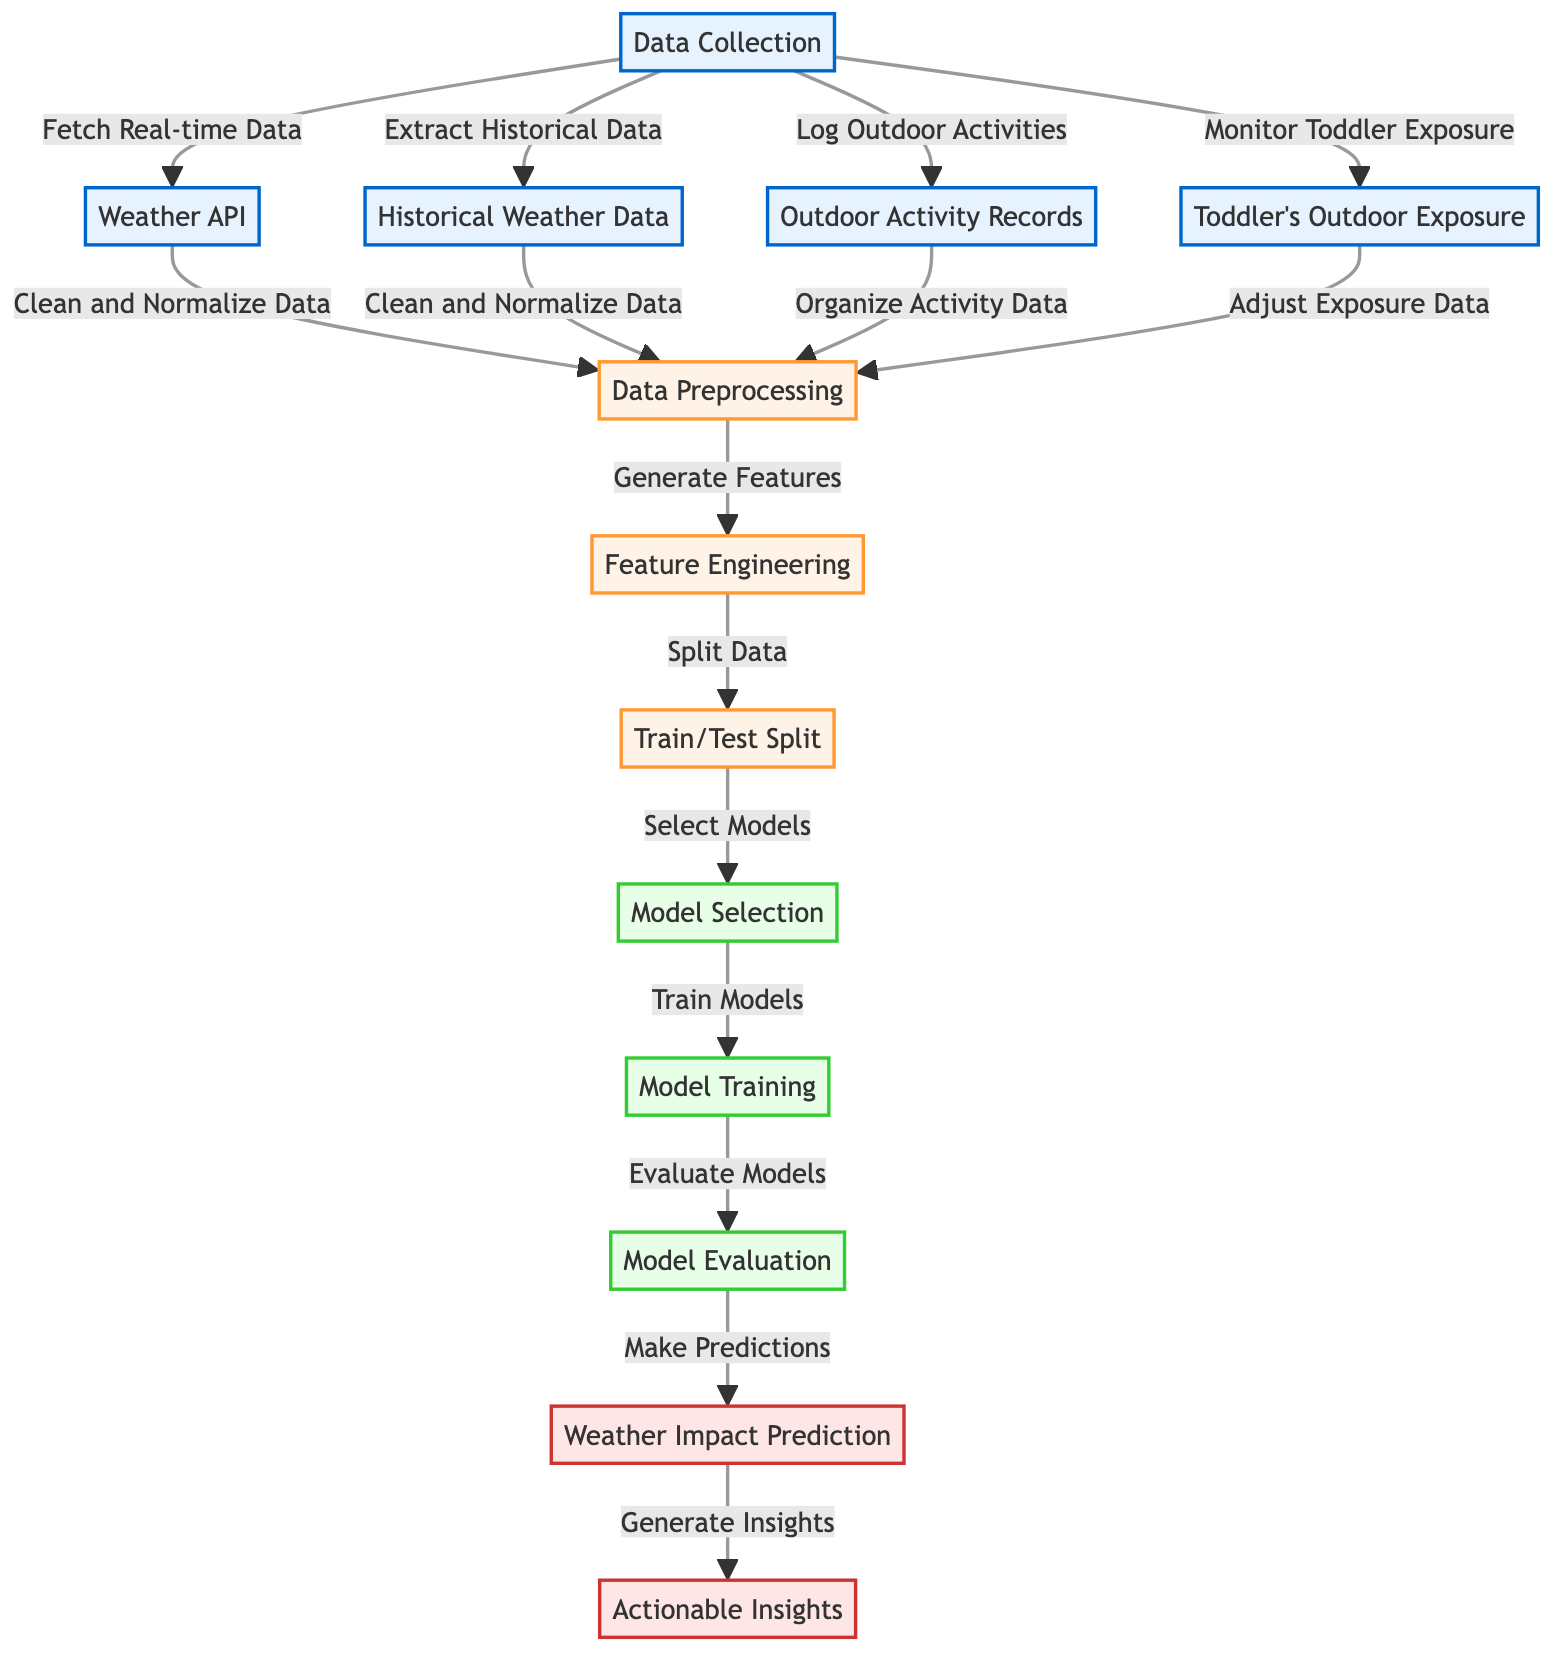What are the primary data sources in this diagram? There are four primary data sources indicated in the diagram: Weather API, Historical Weather Data, Outdoor Activity Records, and Toddler's Outdoor Exposure. Each of these nodes represents a source from which data is collected for the prediction model.
Answer: Weather API, Historical Weather Data, Outdoor Activity Records, Toddler's Outdoor Exposure How many modeling nodes are included in the diagram? The diagram contains three modeling nodes: Model Selection, Model Training, and Model Evaluation. These nodes are part of the machine learning process that deals with building and assessing the model.
Answer: Three What does the node "Data Collection" connect to? The "Data Collection" node is connected to four other nodes: Weather API, Historical Weather Data, Outdoor Activity Records, and Toddler's Outdoor Exposure, showing the variety of data being collected for analysis.
Answer: Weather API, Historical Weather Data, Outdoor Activity Records, Toddler's Outdoor Exposure What process follows "Data Preprocessing"? After "Data Preprocessing," the next step is "Feature Engineering." This indicates that the data is transformed and structured before it is split into training and testing subsets.
Answer: Feature Engineering Which node provides actionable information for users? The "Actionable Insights" node provides actionable information for users based on the predictions made. This indicates the final output of the machine learning model that can offer practical advice or guidance.
Answer: Actionable Insights How does the prediction flow connect to insights in this diagram? The prediction, which represents the model results, flows directly into the "Actionable Insights" node, indicating that predictions lead to generating useful insights for outdoor activities.
Answer: Actionable Insights Which nodes are categorized under processing? The processing category includes Data Preprocessing, Feature Engineering, and Train/Test Split. These nodes represent steps that involve preparing and structuring the collected data for modeling purposes.
Answer: Data Preprocessing, Feature Engineering, Train/Test Split What is the final output of the machine learning process represented in the diagram? The final output of the process is represented by the "Actionable Insights" node, which signifies the end goal of making predictions that can influence outdoor activities.
Answer: Actionable Insights 